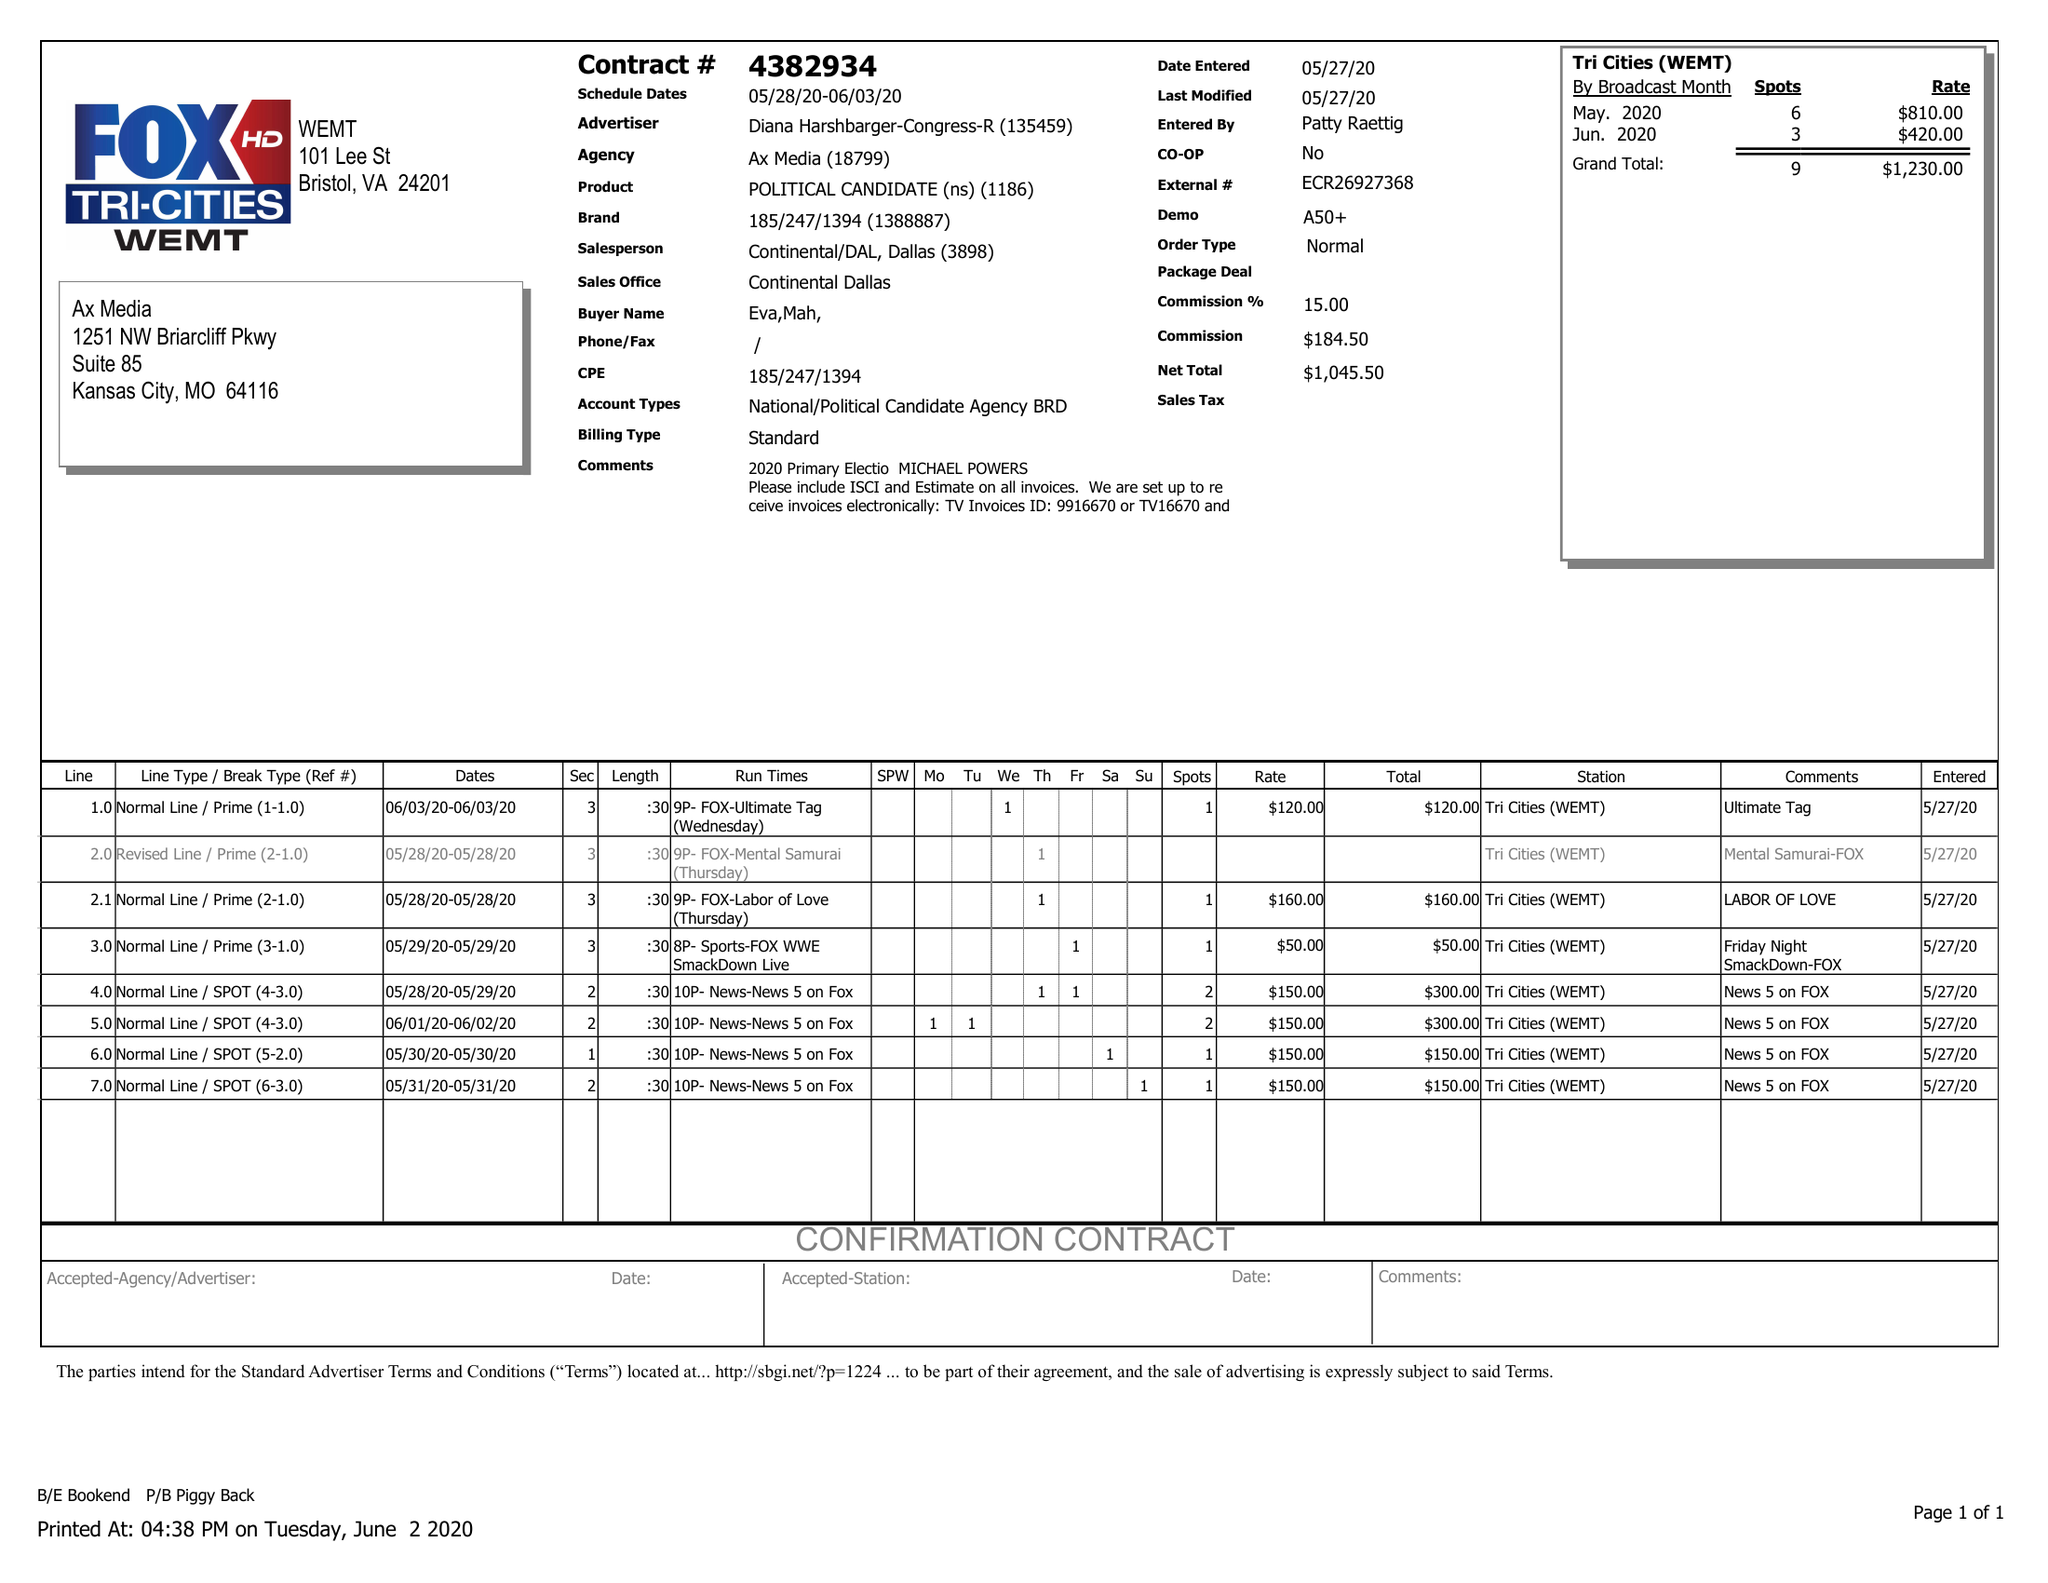What is the value for the contract_num?
Answer the question using a single word or phrase. 4382934 